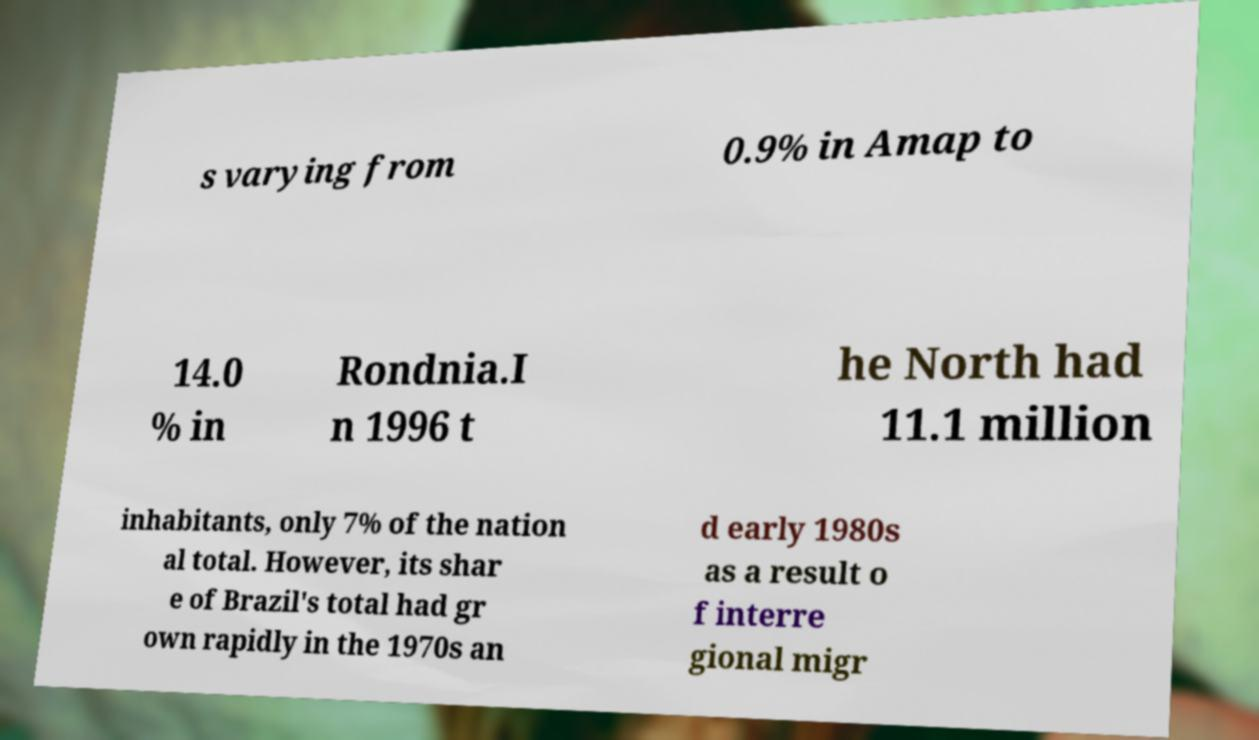Could you assist in decoding the text presented in this image and type it out clearly? s varying from 0.9% in Amap to 14.0 % in Rondnia.I n 1996 t he North had 11.1 million inhabitants, only 7% of the nation al total. However, its shar e of Brazil's total had gr own rapidly in the 1970s an d early 1980s as a result o f interre gional migr 